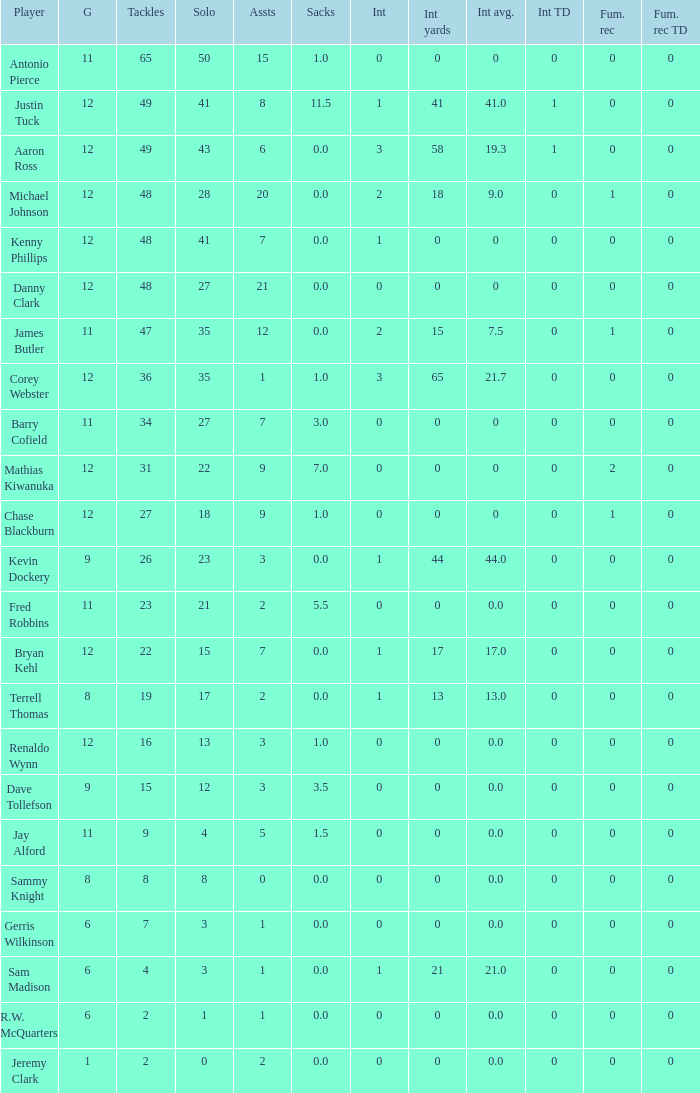Name the least amount of tackles for danny clark 48.0. 